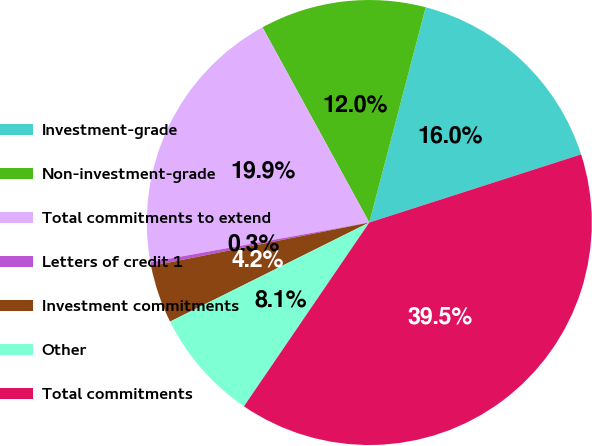Convert chart. <chart><loc_0><loc_0><loc_500><loc_500><pie_chart><fcel>Investment-grade<fcel>Non-investment-grade<fcel>Total commitments to extend<fcel>Letters of credit 1<fcel>Investment commitments<fcel>Other<fcel>Total commitments<nl><fcel>15.97%<fcel>12.05%<fcel>19.88%<fcel>0.29%<fcel>4.21%<fcel>8.13%<fcel>39.48%<nl></chart> 